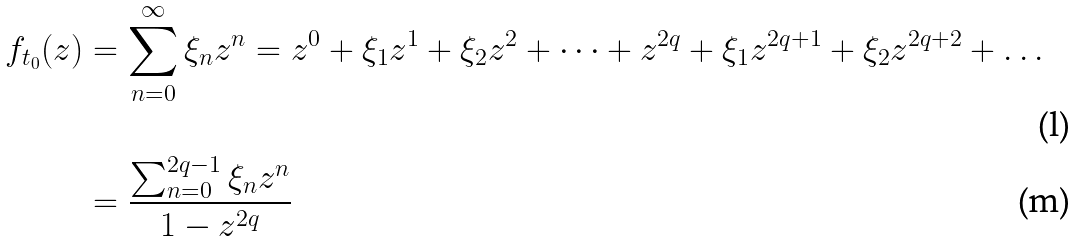Convert formula to latex. <formula><loc_0><loc_0><loc_500><loc_500>f _ { t _ { 0 } } ( z ) & = \sum _ { n = 0 } ^ { \infty } \xi _ { n } z ^ { n } = z ^ { 0 } + \xi _ { 1 } z ^ { 1 } + \xi _ { 2 } z ^ { 2 } + \dots + z ^ { 2 q } + \xi _ { 1 } z ^ { 2 q + 1 } + \xi _ { 2 } z ^ { 2 q + 2 } + \dots \\ & = \frac { \sum _ { n = 0 } ^ { 2 q - 1 } \xi _ { n } z ^ { n } } { 1 - z ^ { 2 q } }</formula> 